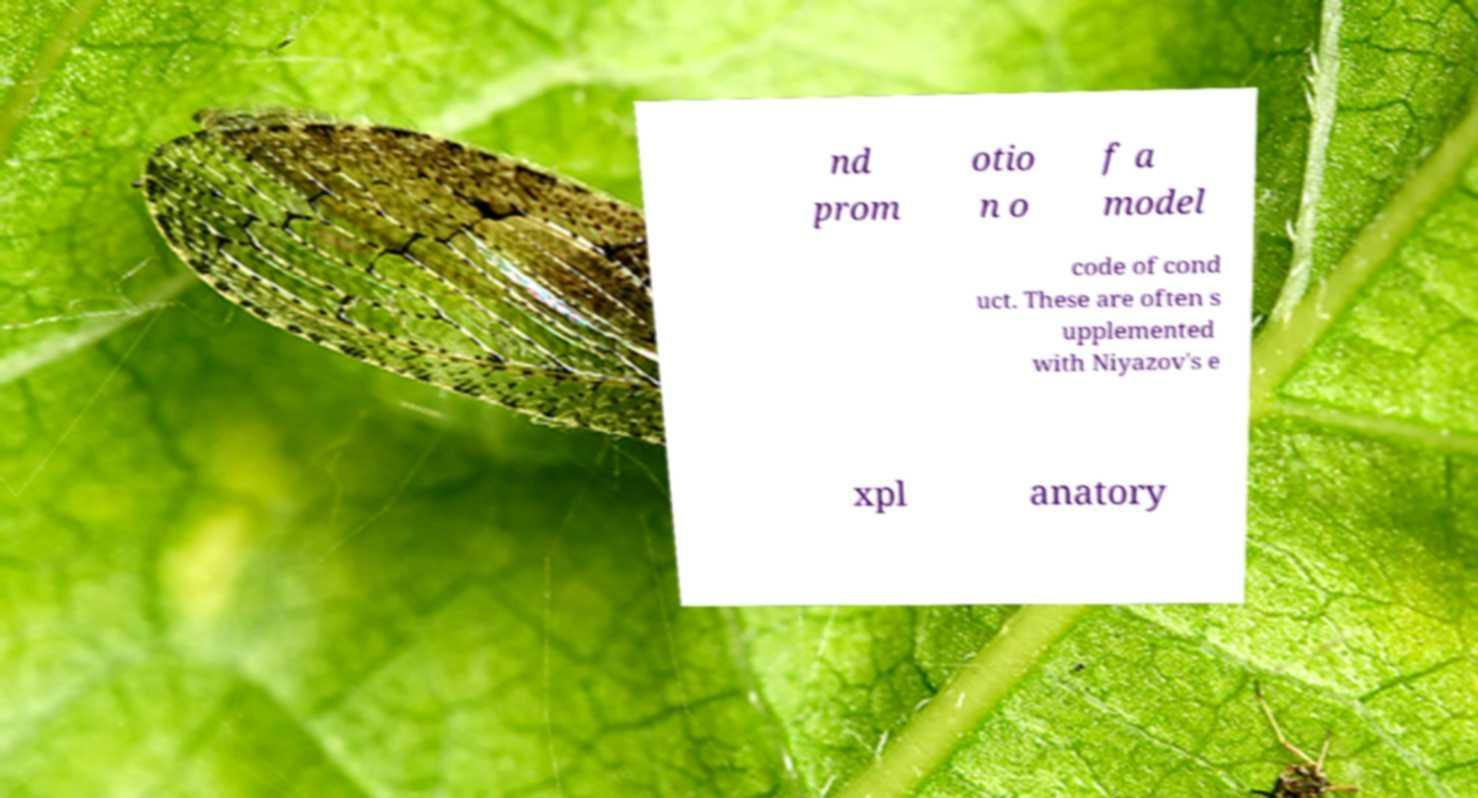For documentation purposes, I need the text within this image transcribed. Could you provide that? nd prom otio n o f a model code of cond uct. These are often s upplemented with Niyazov's e xpl anatory 